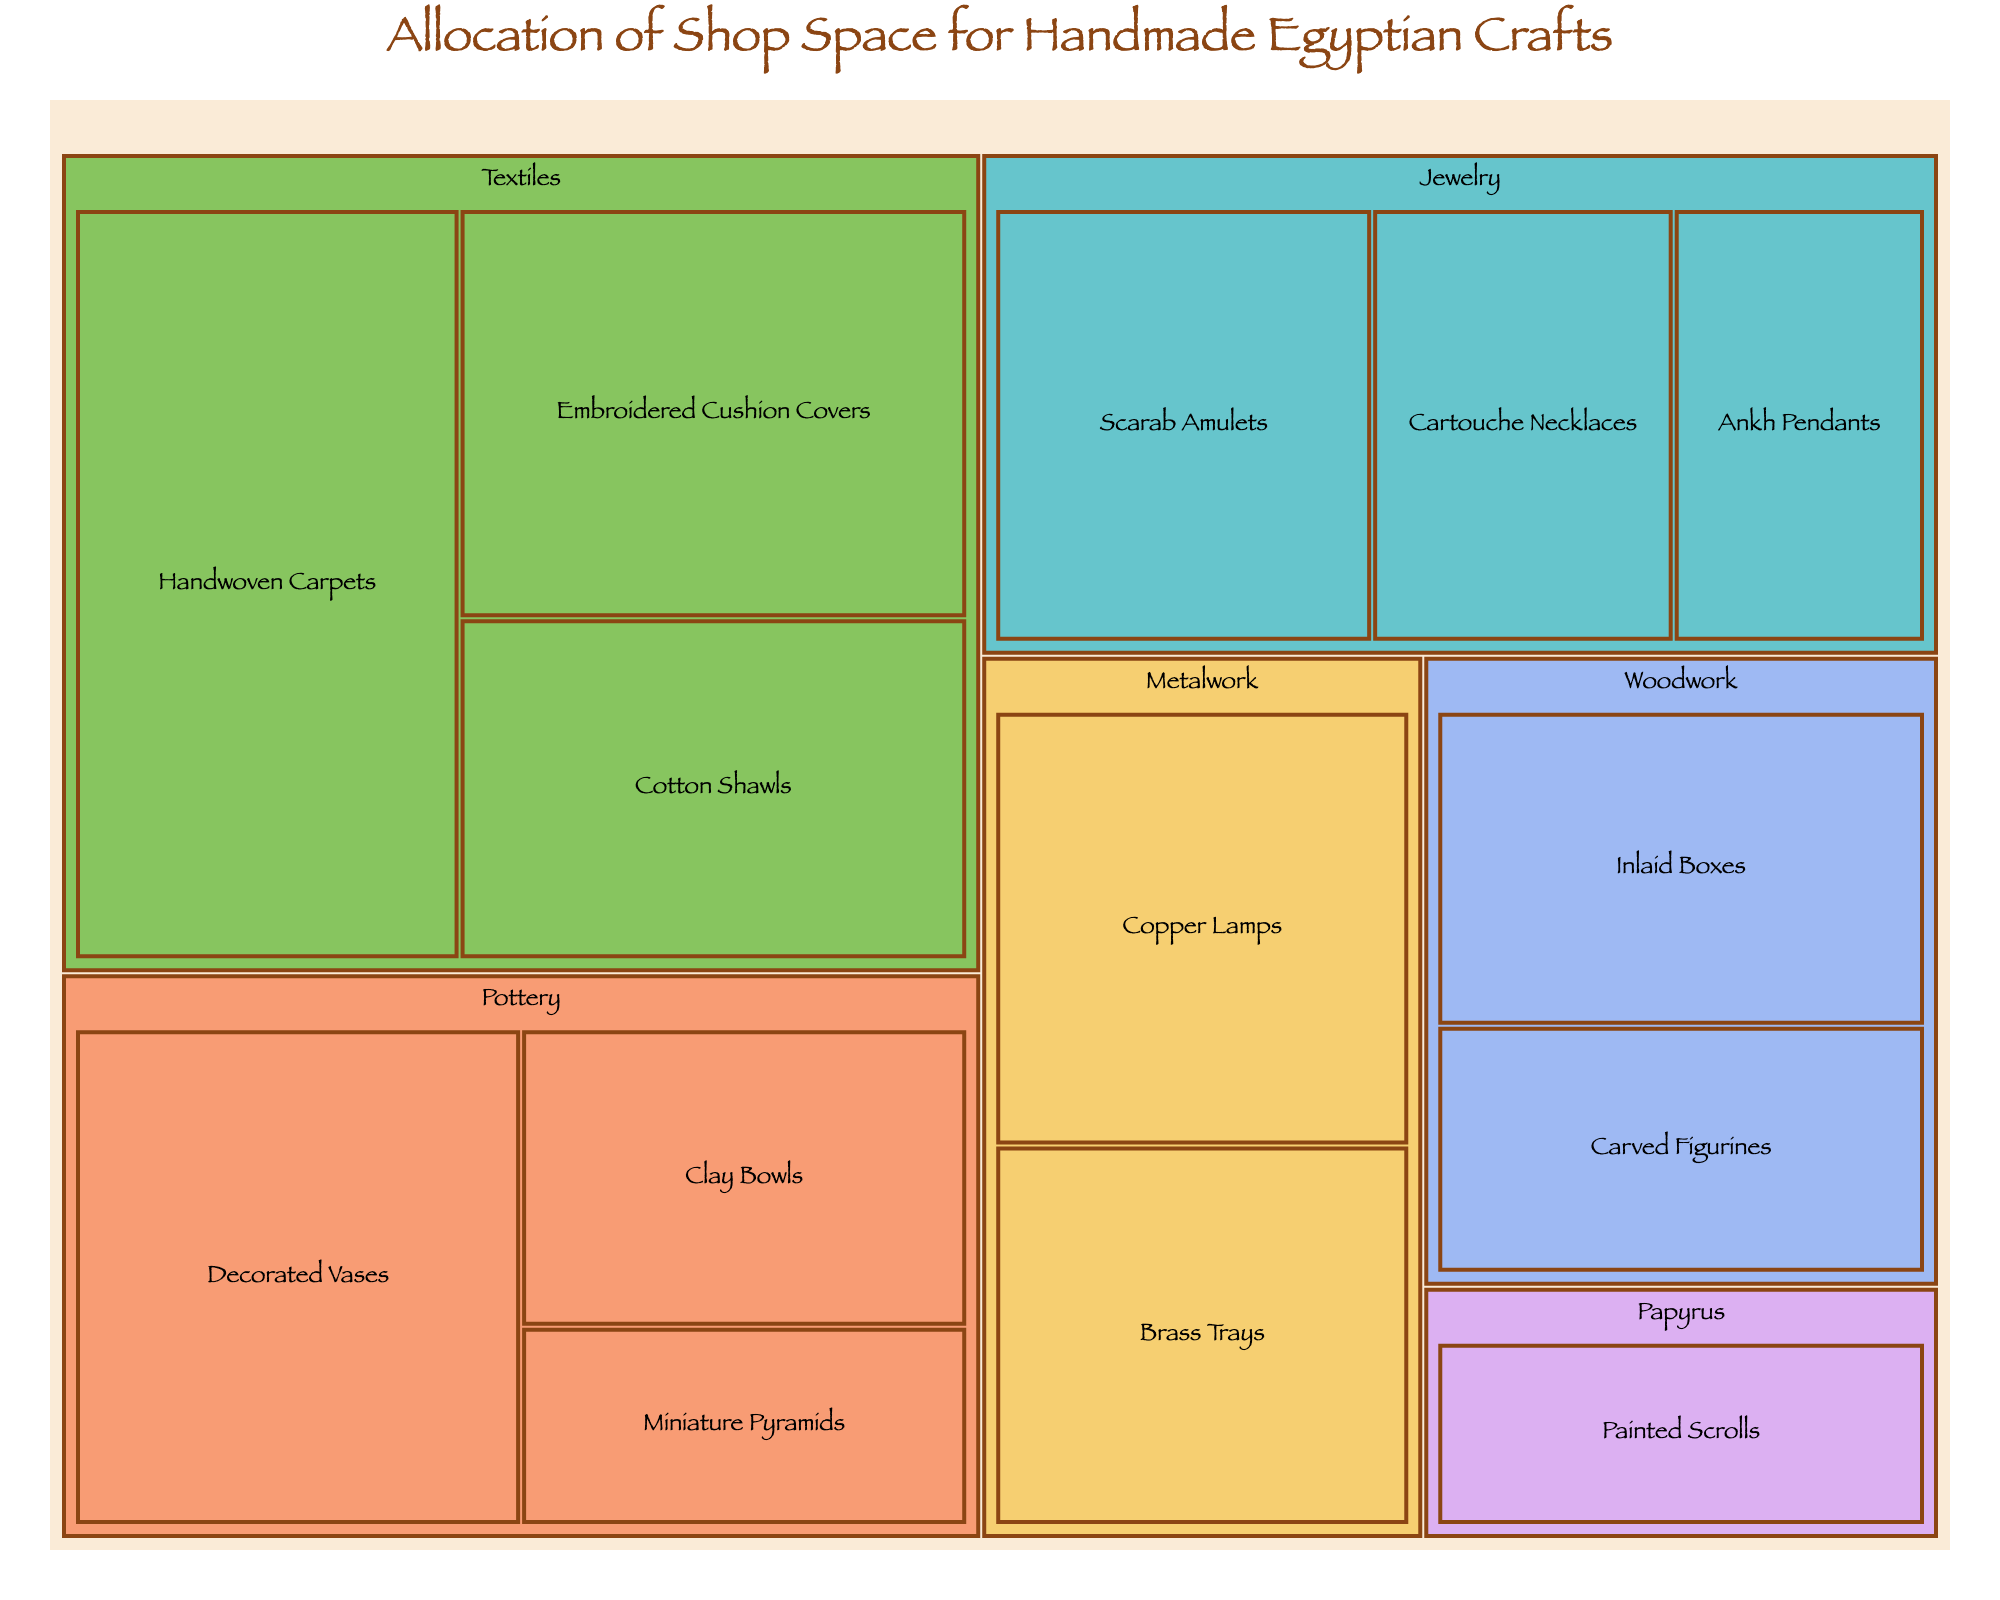How much space is allocated to Jewelry? To determine the space for Jewelry, sum up the space allocated to each subcategory within Jewelry: Scarab Amulets (15), Ankh Pendants (10), Cartouche Necklaces (12). So, 15 + 10 + 12 = 37 sq ft.
Answer: 37 sq ft What's the category with the highest allocation of shop space? To find the category with the highest space, compare the total space of all main categories. Textiles has Handwoven Carpets (25), Embroidered Cushion Covers (18), and Cotton Shawls (15), making it 25 + 18 + 15 = 58 sq ft, which is the highest.
Answer: Textiles Which subcategory in Pottery takes the most space? For Pottery, compare the individual spaces of each subcategory: Decorated Vases (20), Clay Bowls (12), Miniature Pyramids (8). The highest space allocation is for Decorated Vases at 20 sq ft.
Answer: Decorated Vases How does the space allocated to Copper Lamps compare to that allocated to Inlaid Boxes? Look at the space for Copper Lamps (16 sq ft) and Inlaid Boxes (14 sq ft). Copper Lamps have 2 sq ft more space than Inlaid Boxes.
Answer: Copper Lamps have 2 sq ft more What's the total space allocated to Woodwork and Metalwork combined? Sum the spaces for Woodwork (Inlaid Boxes: 14, Carved Figurines: 11) and Metalwork (Copper Lamps: 16, Brass Trays: 14). So, 14 + 11 + 16 + 14 = 55 sq ft.
Answer: 55 sq ft Identify the smallest allocated space among all subcategories. Identify the smallest space among all subcategories in the treemap. The smallest is Miniature Pyramids with 8 sq ft.
Answer: Miniature Pyramids What is the average space allocated per subcategory in Pottery? Calculate the average by summing the spaces of Pottery's subcategories: Decorated Vases (20), Clay Bowls (12), Miniature Pyramids (8). Average = (20 + 12 + 8) / 3 = 40/3 ≈ 13.33 sq ft.
Answer: ~13.33 sq ft Which subcategory under Textiles has the second highest space allocation? List the spaces for subcategories under Textiles: Handwoven Carpets (25), Embroidered Cushion Covers (18), Cotton Shawls (15). The second highest is Embroidered Cushion Covers with 18 sq ft.
Answer: Embroidered Cushion Covers How does the total space for Papyrus compare to that for Brass Trays? Sum the space for Papyrus subcategory (Painted Scrolls: 10) and the space for Brass Trays (14). Papyrus has 4 sq ft less space allocated than Brass Trays.
Answer: Papyrus has 4 sq ft less 